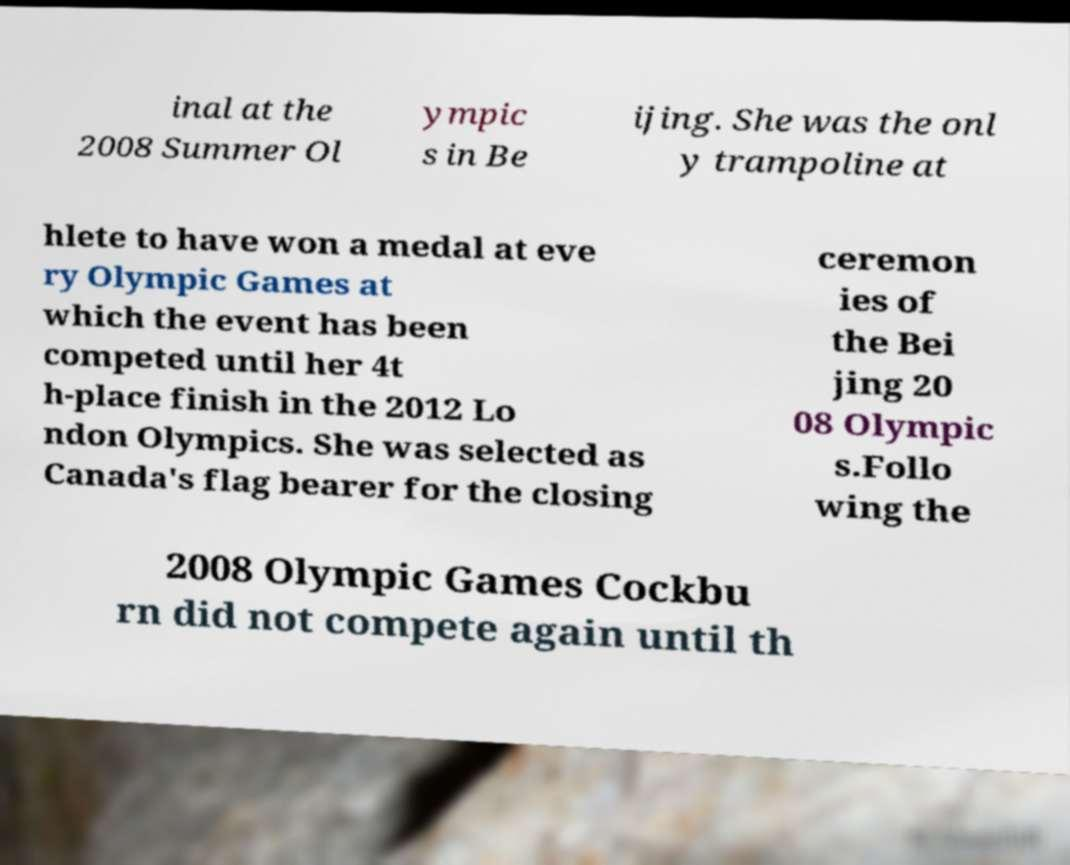There's text embedded in this image that I need extracted. Can you transcribe it verbatim? inal at the 2008 Summer Ol ympic s in Be ijing. She was the onl y trampoline at hlete to have won a medal at eve ry Olympic Games at which the event has been competed until her 4t h-place finish in the 2012 Lo ndon Olympics. She was selected as Canada's flag bearer for the closing ceremon ies of the Bei jing 20 08 Olympic s.Follo wing the 2008 Olympic Games Cockbu rn did not compete again until th 